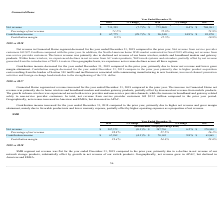According to Netgear's financial document, How much did the net revenue from service provider customers decrease from 2018 to 2019? According to the financial document, $27.8 million. The relevant text states: "customers fell $27.8 million compared with the prior year. In addition, the North American home WiFi market contracted in fiscal..." Also, What accounts for the increase in net revenue in 2018? Due to home wireless and broadband modem and modem gateway products, partially offset by decreased net revenue from mobile products.. The document states: "revenue was primarily due to home wireless and broadband modem and modem gateway products, partially offset by decreased net revenue from mobile produ..." Also, Which region did the net revenue decrease in 2018? According to the financial document, APAC. The relevant text states: "increased in Americas and EMEA, but decreased in APAC...." Also, can you calculate: What was the percentage change in net revenue from 2017 to 2019? To answer this question, I need to perform calculations using the financial data. The calculation is: (711,391 - 768,261)/768,261 , which equals -7.4 (percentage). This is based on the information: "Net revenue $ 711,391 (7.7)% $ 771,060 0.4% $ 768,261 Net revenue $ 711,391 (7.7)% $ 771,060 0.4% $ 768,261..." The key data points involved are: 711,391, 768,261. Additionally, In which year is the percentage of net revenue the lowest? According to the financial document, 2019. The relevant text states: "2019 % Change 2018 % Change 2017..." Also, can you calculate: What was the change in contribution income from 2018 to 2019? Based on the calculation: $67,775 - $96,340 , the result is -28565 (in thousands). This is based on the information: "Contribution income $ 67,775 (29.7)% $ 96,340 14.9% $ 83,870 Contribution income $ 67,775 (29.7)% $ 96,340 14.9% $ 83,870..." The key data points involved are: 67,775, 96,340. 